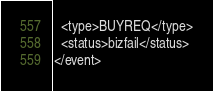<code> <loc_0><loc_0><loc_500><loc_500><_XML_>  <type>BUYREQ</type>
  <status>bizfail</status>
</event>
</code> 